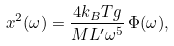<formula> <loc_0><loc_0><loc_500><loc_500>x ^ { 2 } ( \omega ) = \frac { 4 k _ { B } T g } { M L ^ { \prime } \omega ^ { 5 } } \, { \Phi ( \omega ) } ,</formula> 